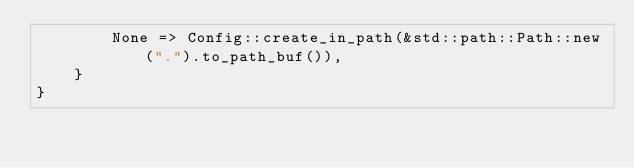Convert code to text. <code><loc_0><loc_0><loc_500><loc_500><_Rust_>        None => Config::create_in_path(&std::path::Path::new(".").to_path_buf()),
    }
}
</code> 